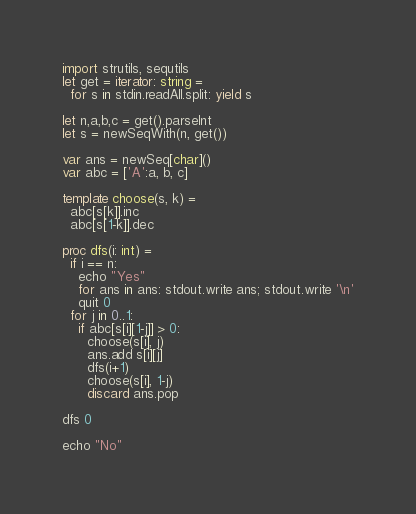Convert code to text. <code><loc_0><loc_0><loc_500><loc_500><_Nim_>import strutils, sequtils
let get = iterator: string =
  for s in stdin.readAll.split: yield s

let n,a,b,c = get().parseInt
let s = newSeqWith(n, get())

var ans = newSeq[char]()
var abc = ['A':a, b, c]

template choose(s, k) =
  abc[s[k]].inc
  abc[s[1-k]].dec

proc dfs(i: int) =
  if i == n:
    echo "Yes"
    for ans in ans: stdout.write ans; stdout.write '\n'
    quit 0
  for j in 0..1:
    if abc[s[i][1-j]] > 0:
      choose(s[i], j)
      ans.add s[i][j]
      dfs(i+1)
      choose(s[i], 1-j)
      discard ans.pop

dfs 0

echo "No"</code> 